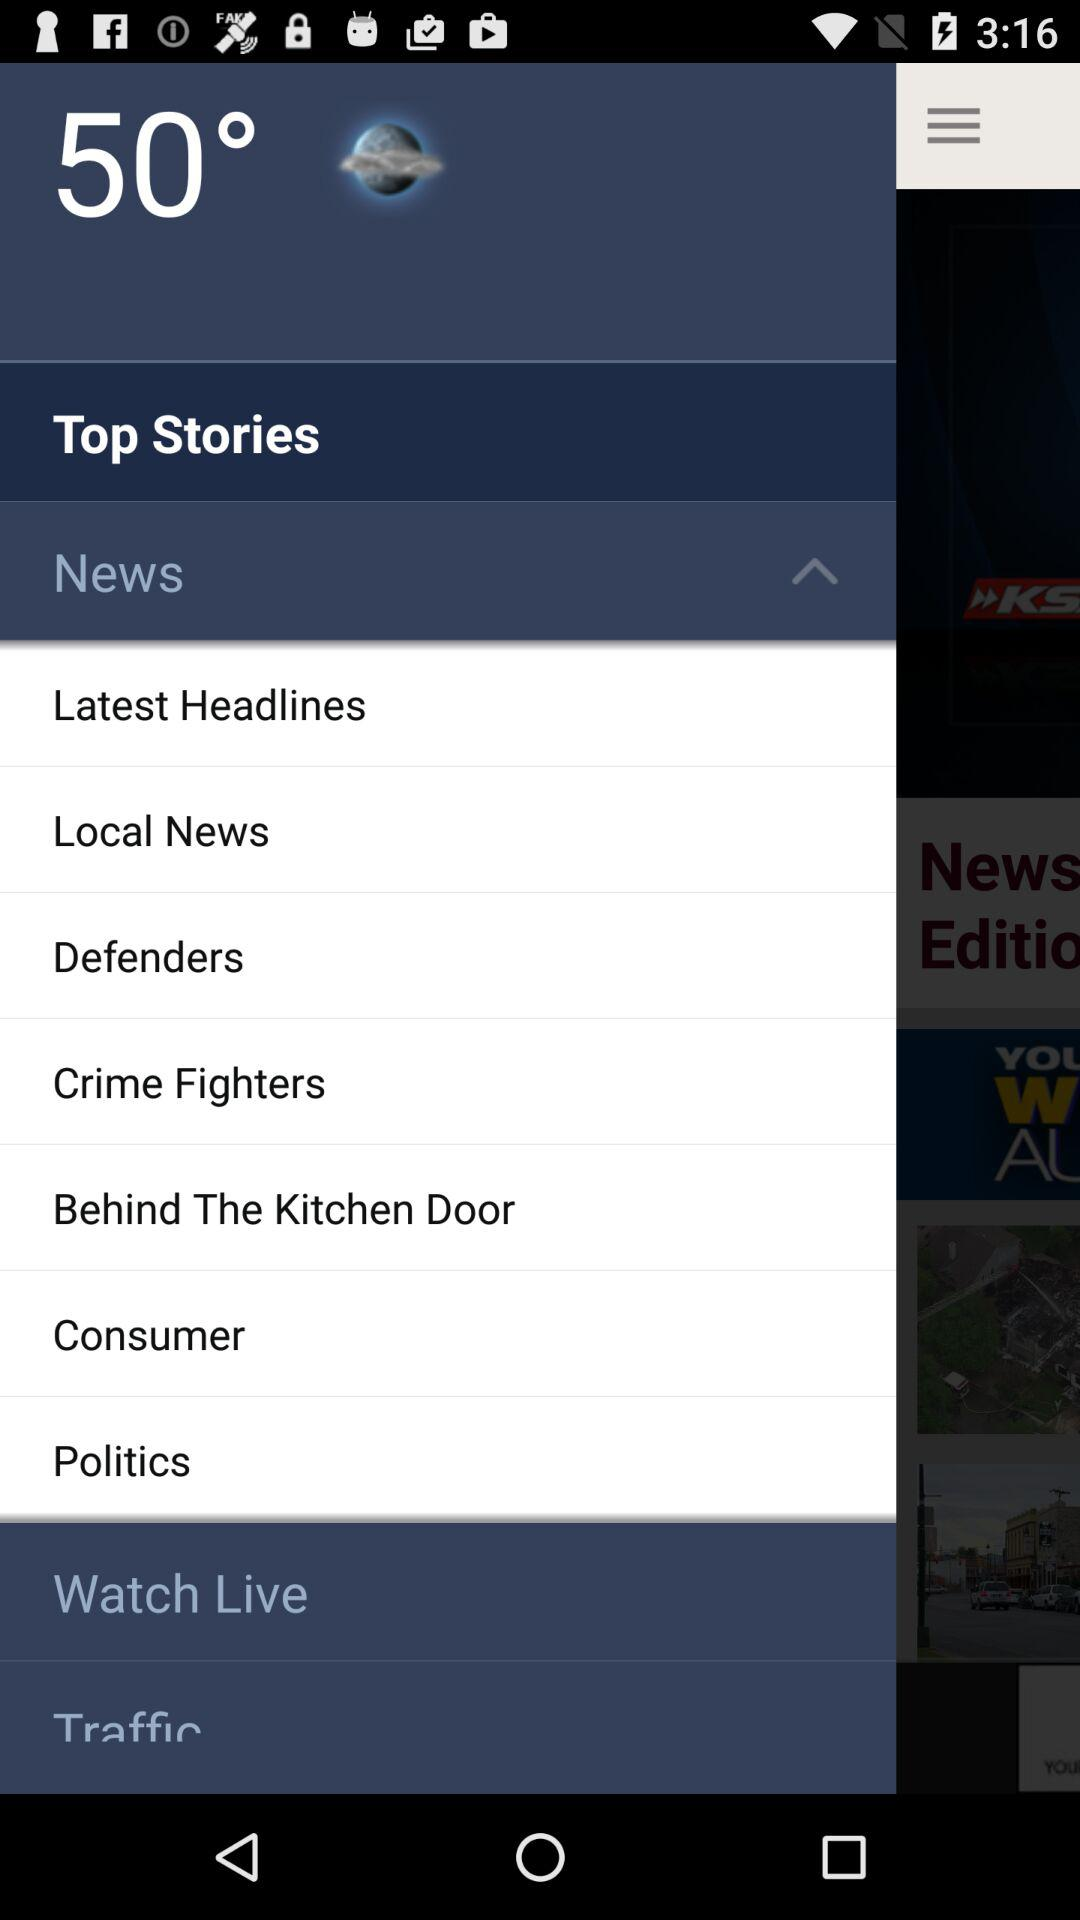What is the temperature? The temperature is 50 degrees. 